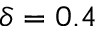<formula> <loc_0><loc_0><loc_500><loc_500>\delta = 0 . 4</formula> 